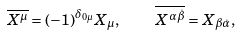<formula> <loc_0><loc_0><loc_500><loc_500>\overline { X ^ { \mu } } = ( - 1 ) ^ { \delta _ { 0 \mu } } X _ { \mu } , \text {\quad} \overline { X ^ { \alpha \dot { \beta } } } = X _ { \beta \dot { \alpha } } ,</formula> 